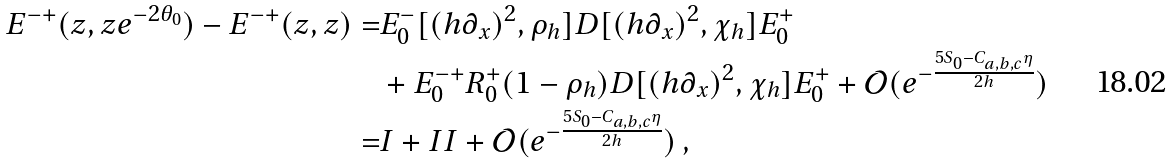Convert formula to latex. <formula><loc_0><loc_0><loc_500><loc_500>E ^ { - + } ( z , z e ^ { - 2 \theta _ { 0 } } ) - E ^ { - + } ( z , z ) = & E _ { 0 } ^ { - } [ ( h \partial _ { x } ) ^ { 2 } , \rho _ { h } ] D [ ( h \partial _ { x } ) ^ { 2 } , \chi _ { h } ] E _ { 0 } ^ { + } \\ & + E _ { 0 } ^ { - + } R _ { 0 } ^ { + } ( 1 - \rho _ { h } ) D [ ( h \partial _ { x } ) ^ { 2 } , \chi _ { h } ] E _ { 0 } ^ { + } + \mathcal { O } ( e ^ { - \frac { 5 S _ { 0 } - C _ { a , b , c } \eta } { 2 h } } ) \\ = & I + I I + \mathcal { O } ( e ^ { - \frac { 5 S _ { 0 } - C _ { a , b , c } \eta } { 2 h } } ) \, ,</formula> 